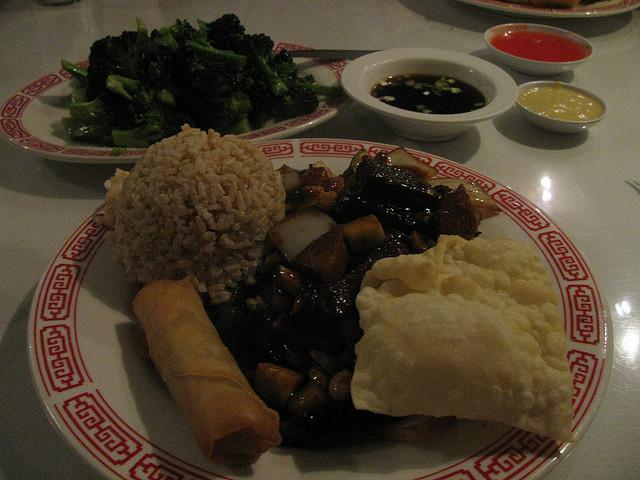What is on the plate?
Quick response, please. Chinese food. What type of food is on the plate?
Concise answer only. Chinese. Are they having a party?
Be succinct. No. What may they be celebrating?
Give a very brief answer. Chinese new year. Is this a healthy meal?
Keep it brief. Yes. How many dishes are in the picture?
Keep it brief. 2. What color is the table?
Keep it brief. White. What vegetable has its own plate?
Keep it brief. Broccoli. What kind of sauce is in the largest ramekin?
Be succinct. Soy. What kind of food is this?
Quick response, please. Chinese. What kind of fish is on the plate?
Be succinct. None. Is the plate full?
Quick response, please. Yes. What is the table made of?
Concise answer only. Plastic. Does this image contain a pie pan?
Concise answer only. No. What is the food theme?
Short answer required. Chinese. What type of cuisine is this?
Short answer required. Chinese. Should this food be eaten with chopsticks?
Concise answer only. Yes. What colors are on the plate?
Give a very brief answer. Red and white. What color is the bowl?
Be succinct. White. 